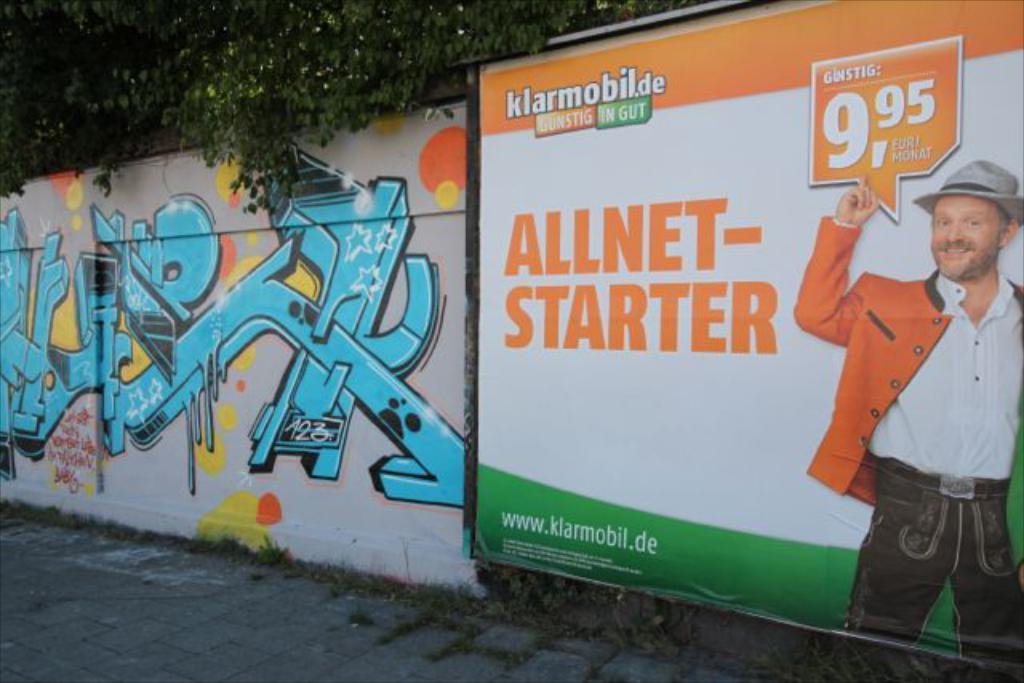<image>
Summarize the visual content of the image. a billboard for All Net Starter has orange and green colors on it 